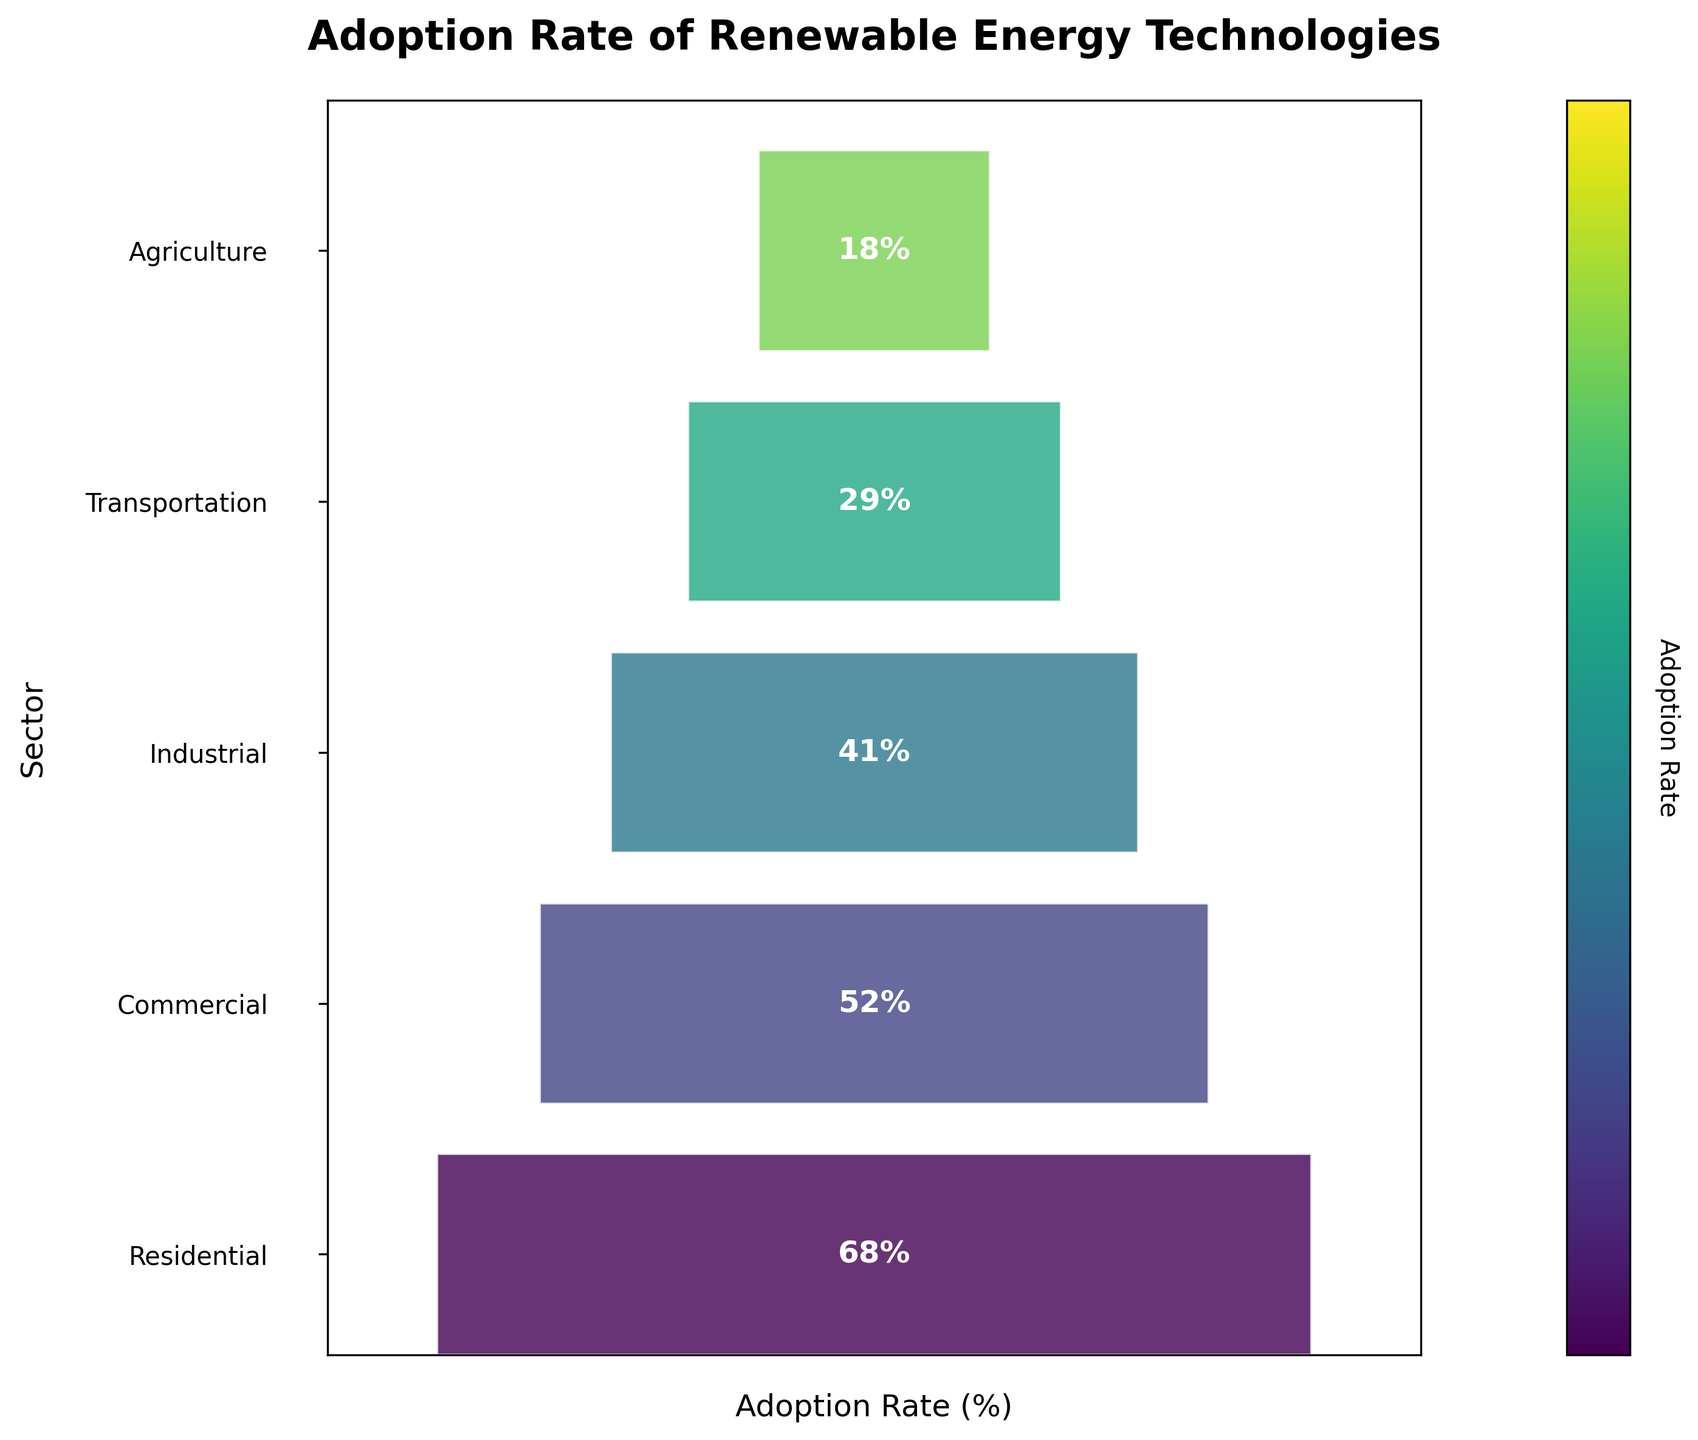What's the adoption rate for the Residential sector? The rate is labeled directly on the figure as 68%.
Answer: 68% What sector has the lowest adoption rate for renewable energy? The Agriculture sector is at the bottom of the funnel, indicating it has the lowest adoption rate.
Answer: Agriculture How many sectors classify the adoption rates of renewable energy technologies? By counting the distinct segments in the funnel, there are five sectors listed.
Answer: 5 Which sector has a higher adoption rate: Industrial or Transportation? The Industrial sector has an adoption rate of 41%, while the Transportation sector has an adoption rate of 29%.
Answer: Industrial What is the difference between the highest and lowest adoption rates? The highest adoption rate is 68% (Residential) and the lowest is 18% (Agriculture). The difference is 68% - 18% = 50%.
Answer: 50% Among the given sectors, what is the average adoption rate? Sum the adoption rates (68 + 52 + 41 + 29 + 18) = 208. Divide by the number of sectors, 208 / 5 = 41.6%.
Answer: 41.6% Which sector is closest to the median adoption rate and what is its rate? Sorting the adoption rates: [18, 29, 41, 52, 68], the median is 41% which is the rate for the Industrial sector.
Answer: Industrial (41%) Are there more sectors with adoption rates above 50% than below 30%? One sector has rates above 50% (Residential and Commercial), and two sectors have rates below 30% (Transportation and Agriculture). Therefore, fewer sectors have rates above 50% than below 30%.
Answer: No How does the adoption rate of the Commercial sector compare with that of the Residential sector? The Commercial sector has an adoption rate of 52%, which is less than the Residential sector's rate of 68%.
Answer: Less How does the width of the funnel segments relate to the adoption rates? The width of the funnel segments corresponds to the adoption rates visually: wider segments indicate higher rates, and narrower segments indicate lower rates.
Answer: Higher rates = Wider segments 